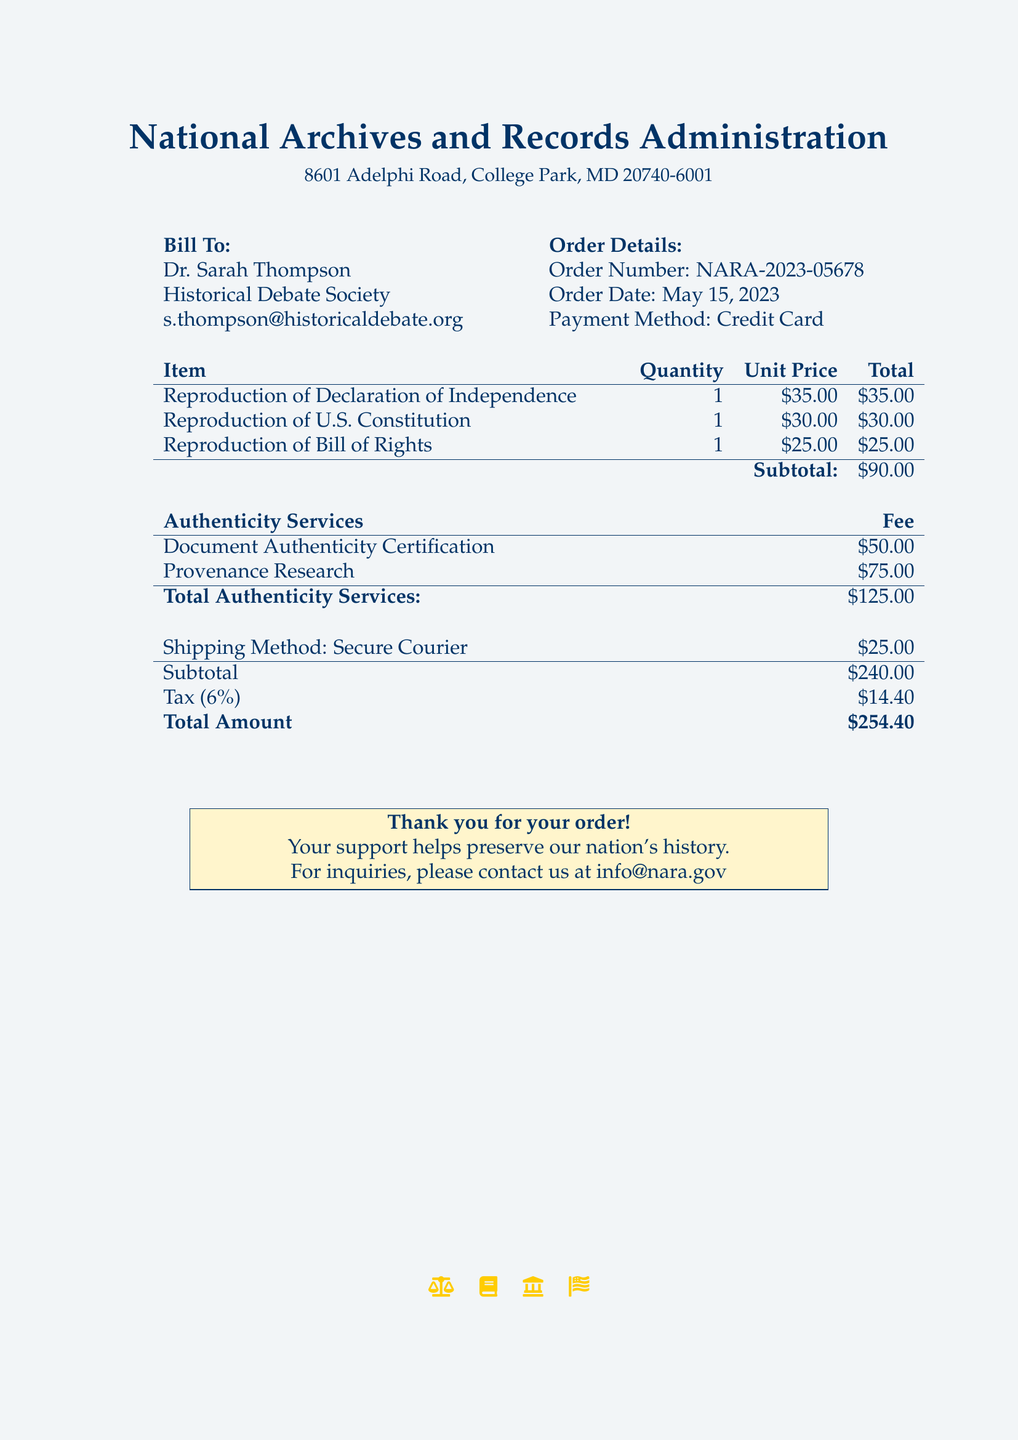What is the total amount? The total amount is listed as the final value at the bottom of the document, which includes all charges.
Answer: $254.40 What is the order date? The order date is specified in the order details section, showing when the order was placed.
Answer: May 15, 2023 Who is the bill to? The recipient's information is found in the beginning section of the document identifying who the order is billed to.
Answer: Dr. Sarah Thompson What is the quantity of the U.S. Constitution reproduction? The quantity of each item is provided in the order details section of the table listing the items.
Answer: 1 What fee is associated with provenance research? The fee for provenance research is noted in the authenticity services section of the document.
Answer: $75.00 What is the subtotal for the reproductions? The subtotal for the reproductions is calculated based on the unit price and quantity listed in the items section.
Answer: $90.00 What shipping method is used? The shipping method is specified in the shipping details section towards the end of the document.
Answer: Secure Courier What is the tax rate applied in the document? The tax rate is mentioned in the summary section of the document where it breaks down the charges.
Answer: 6% What is the total for authenticity services? The total for authenticity services is summarized in the authenticity services section as the sum of certification and research fees.
Answer: $125.00 